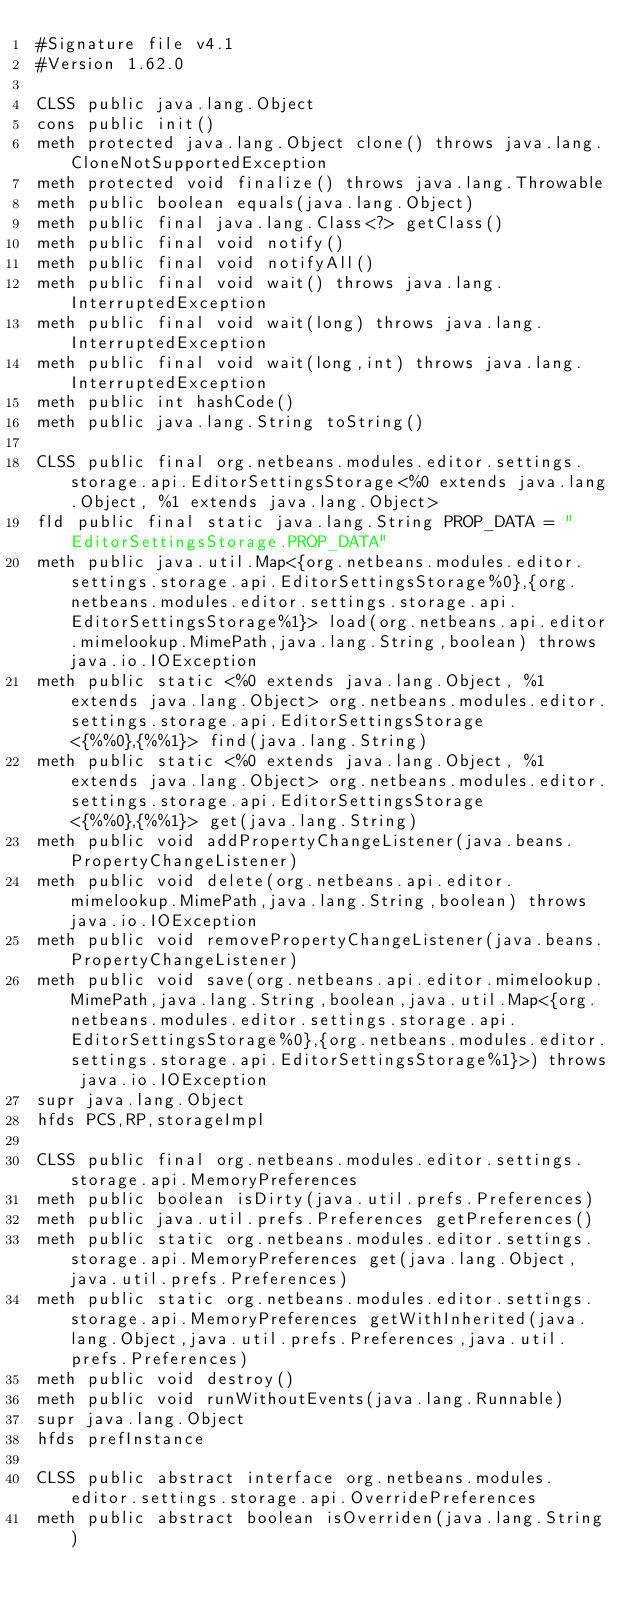Convert code to text. <code><loc_0><loc_0><loc_500><loc_500><_SML_>#Signature file v4.1
#Version 1.62.0

CLSS public java.lang.Object
cons public init()
meth protected java.lang.Object clone() throws java.lang.CloneNotSupportedException
meth protected void finalize() throws java.lang.Throwable
meth public boolean equals(java.lang.Object)
meth public final java.lang.Class<?> getClass()
meth public final void notify()
meth public final void notifyAll()
meth public final void wait() throws java.lang.InterruptedException
meth public final void wait(long) throws java.lang.InterruptedException
meth public final void wait(long,int) throws java.lang.InterruptedException
meth public int hashCode()
meth public java.lang.String toString()

CLSS public final org.netbeans.modules.editor.settings.storage.api.EditorSettingsStorage<%0 extends java.lang.Object, %1 extends java.lang.Object>
fld public final static java.lang.String PROP_DATA = "EditorSettingsStorage.PROP_DATA"
meth public java.util.Map<{org.netbeans.modules.editor.settings.storage.api.EditorSettingsStorage%0},{org.netbeans.modules.editor.settings.storage.api.EditorSettingsStorage%1}> load(org.netbeans.api.editor.mimelookup.MimePath,java.lang.String,boolean) throws java.io.IOException
meth public static <%0 extends java.lang.Object, %1 extends java.lang.Object> org.netbeans.modules.editor.settings.storage.api.EditorSettingsStorage<{%%0},{%%1}> find(java.lang.String)
meth public static <%0 extends java.lang.Object, %1 extends java.lang.Object> org.netbeans.modules.editor.settings.storage.api.EditorSettingsStorage<{%%0},{%%1}> get(java.lang.String)
meth public void addPropertyChangeListener(java.beans.PropertyChangeListener)
meth public void delete(org.netbeans.api.editor.mimelookup.MimePath,java.lang.String,boolean) throws java.io.IOException
meth public void removePropertyChangeListener(java.beans.PropertyChangeListener)
meth public void save(org.netbeans.api.editor.mimelookup.MimePath,java.lang.String,boolean,java.util.Map<{org.netbeans.modules.editor.settings.storage.api.EditorSettingsStorage%0},{org.netbeans.modules.editor.settings.storage.api.EditorSettingsStorage%1}>) throws java.io.IOException
supr java.lang.Object
hfds PCS,RP,storageImpl

CLSS public final org.netbeans.modules.editor.settings.storage.api.MemoryPreferences
meth public boolean isDirty(java.util.prefs.Preferences)
meth public java.util.prefs.Preferences getPreferences()
meth public static org.netbeans.modules.editor.settings.storage.api.MemoryPreferences get(java.lang.Object,java.util.prefs.Preferences)
meth public static org.netbeans.modules.editor.settings.storage.api.MemoryPreferences getWithInherited(java.lang.Object,java.util.prefs.Preferences,java.util.prefs.Preferences)
meth public void destroy()
meth public void runWithoutEvents(java.lang.Runnable)
supr java.lang.Object
hfds prefInstance

CLSS public abstract interface org.netbeans.modules.editor.settings.storage.api.OverridePreferences
meth public abstract boolean isOverriden(java.lang.String)
</code> 